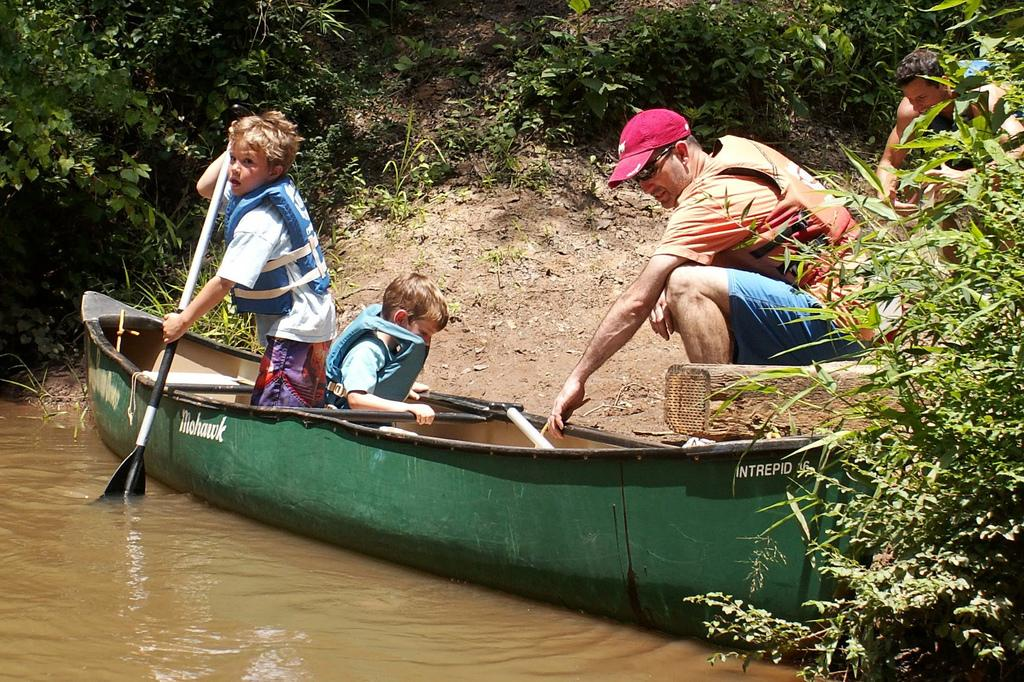What are the people in the image doing? The people in the image are sitting on a boat. What is visible at the bottom of the image? There is water visible at the bottom of the image. What can be seen in the background of the image? There are trees in the background of the image. What type of bottle is floating in the water next to the boat? There is no bottle present in the image; only people, a boat, water, and trees are visible. 